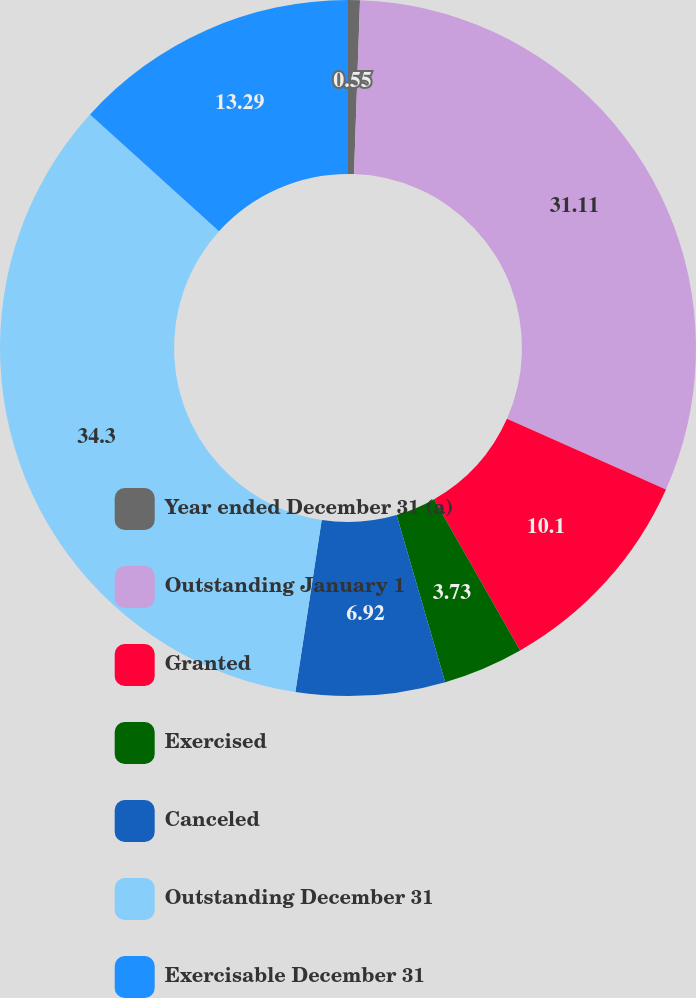Convert chart to OTSL. <chart><loc_0><loc_0><loc_500><loc_500><pie_chart><fcel>Year ended December 31 (a)<fcel>Outstanding January 1<fcel>Granted<fcel>Exercised<fcel>Canceled<fcel>Outstanding December 31<fcel>Exercisable December 31<nl><fcel>0.55%<fcel>31.11%<fcel>10.1%<fcel>3.73%<fcel>6.92%<fcel>34.29%<fcel>13.29%<nl></chart> 